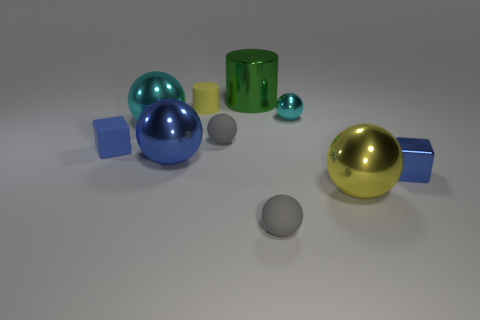Subtract all small rubber balls. How many balls are left? 4 Subtract all gray spheres. How many spheres are left? 4 Subtract all green cylinders. How many cyan balls are left? 2 Subtract all cubes. How many objects are left? 8 Subtract 1 cylinders. How many cylinders are left? 1 Subtract 0 red cubes. How many objects are left? 10 Subtract all red cubes. Subtract all gray cylinders. How many cubes are left? 2 Subtract all large yellow metal objects. Subtract all rubber spheres. How many objects are left? 7 Add 5 blocks. How many blocks are left? 7 Add 3 big matte balls. How many big matte balls exist? 3 